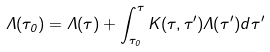<formula> <loc_0><loc_0><loc_500><loc_500>\Lambda ( \tau _ { 0 } ) = \Lambda ( \tau ) + \int ^ { \tau } _ { \tau _ { 0 } } K ( \tau , \tau ^ { \prime } ) \Lambda ( \tau ^ { \prime } ) d \tau ^ { \prime }</formula> 